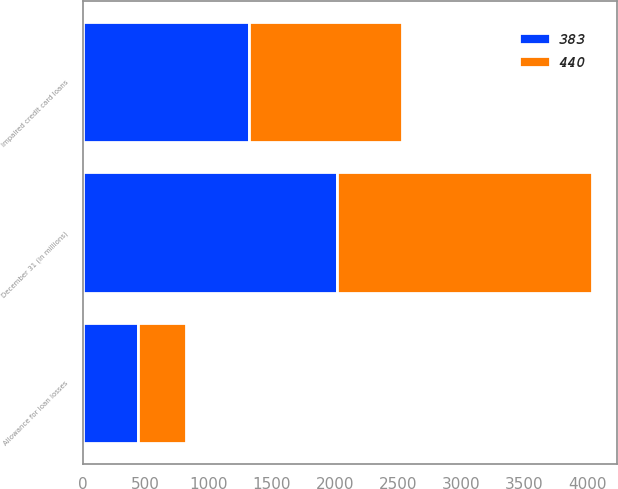Convert chart to OTSL. <chart><loc_0><loc_0><loc_500><loc_500><stacked_bar_chart><ecel><fcel>December 31 (in millions)<fcel>Impaired credit card loans<fcel>Allowance for loan losses<nl><fcel>383<fcel>2018<fcel>1319<fcel>440<nl><fcel>440<fcel>2017<fcel>1215<fcel>383<nl></chart> 